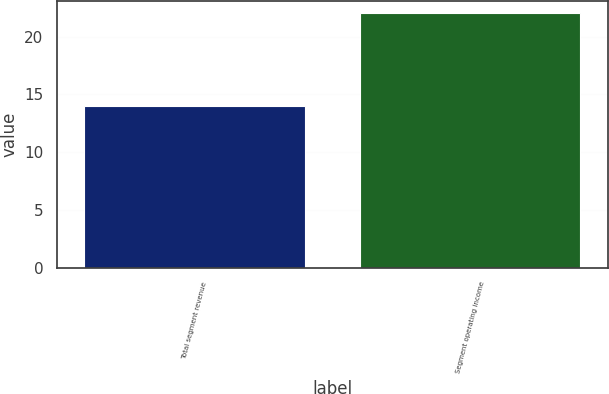Convert chart. <chart><loc_0><loc_0><loc_500><loc_500><bar_chart><fcel>Total segment revenue<fcel>Segment operating income<nl><fcel>14<fcel>22<nl></chart> 